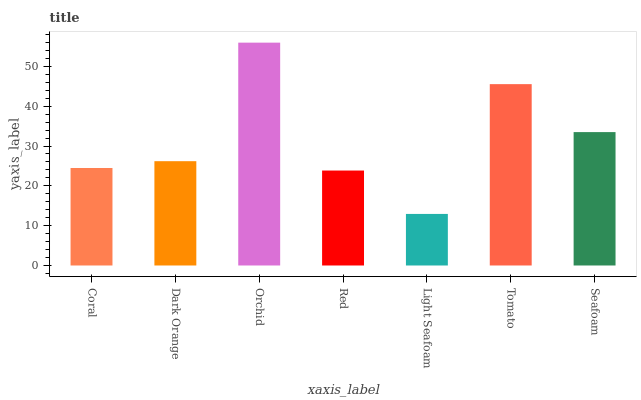Is Light Seafoam the minimum?
Answer yes or no. Yes. Is Orchid the maximum?
Answer yes or no. Yes. Is Dark Orange the minimum?
Answer yes or no. No. Is Dark Orange the maximum?
Answer yes or no. No. Is Dark Orange greater than Coral?
Answer yes or no. Yes. Is Coral less than Dark Orange?
Answer yes or no. Yes. Is Coral greater than Dark Orange?
Answer yes or no. No. Is Dark Orange less than Coral?
Answer yes or no. No. Is Dark Orange the high median?
Answer yes or no. Yes. Is Dark Orange the low median?
Answer yes or no. Yes. Is Seafoam the high median?
Answer yes or no. No. Is Red the low median?
Answer yes or no. No. 